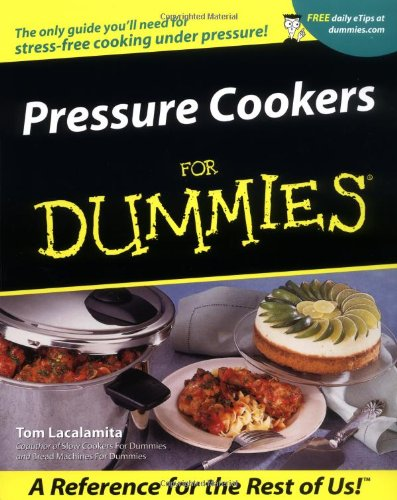What are some of the featured recipes in this book? The book includes a variety of recipes such as desserts like pressure-cooked pear almond tart, main dishes such as beef stew, and innovative pressure cooker uses like making bread. 